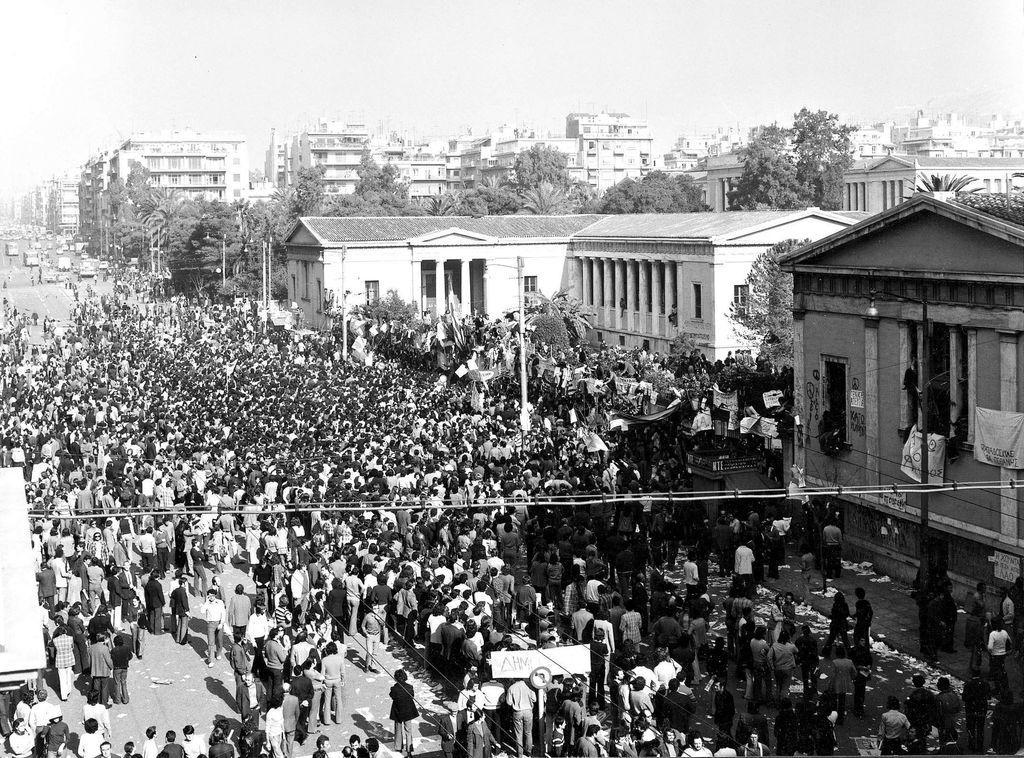Could you give a brief overview of what you see in this image? This is a black and white image. At the bottom I can see a crowd of people walking on the road. In the background, I can see many buildings and trees. At the top I can see the sky. 